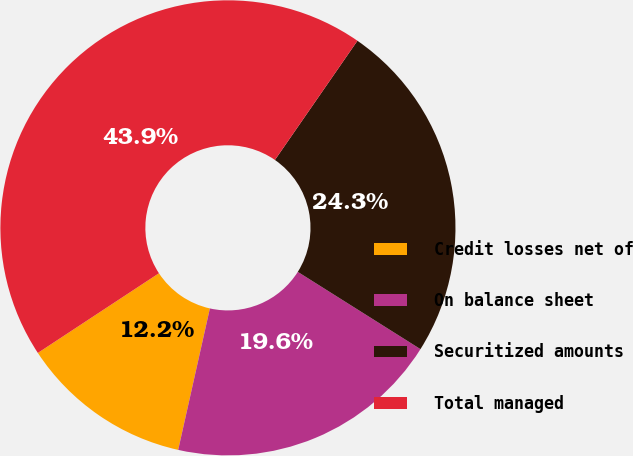Convert chart. <chart><loc_0><loc_0><loc_500><loc_500><pie_chart><fcel>Credit losses net of<fcel>On balance sheet<fcel>Securitized amounts<fcel>Total managed<nl><fcel>12.23%<fcel>19.56%<fcel>24.31%<fcel>43.9%<nl></chart> 